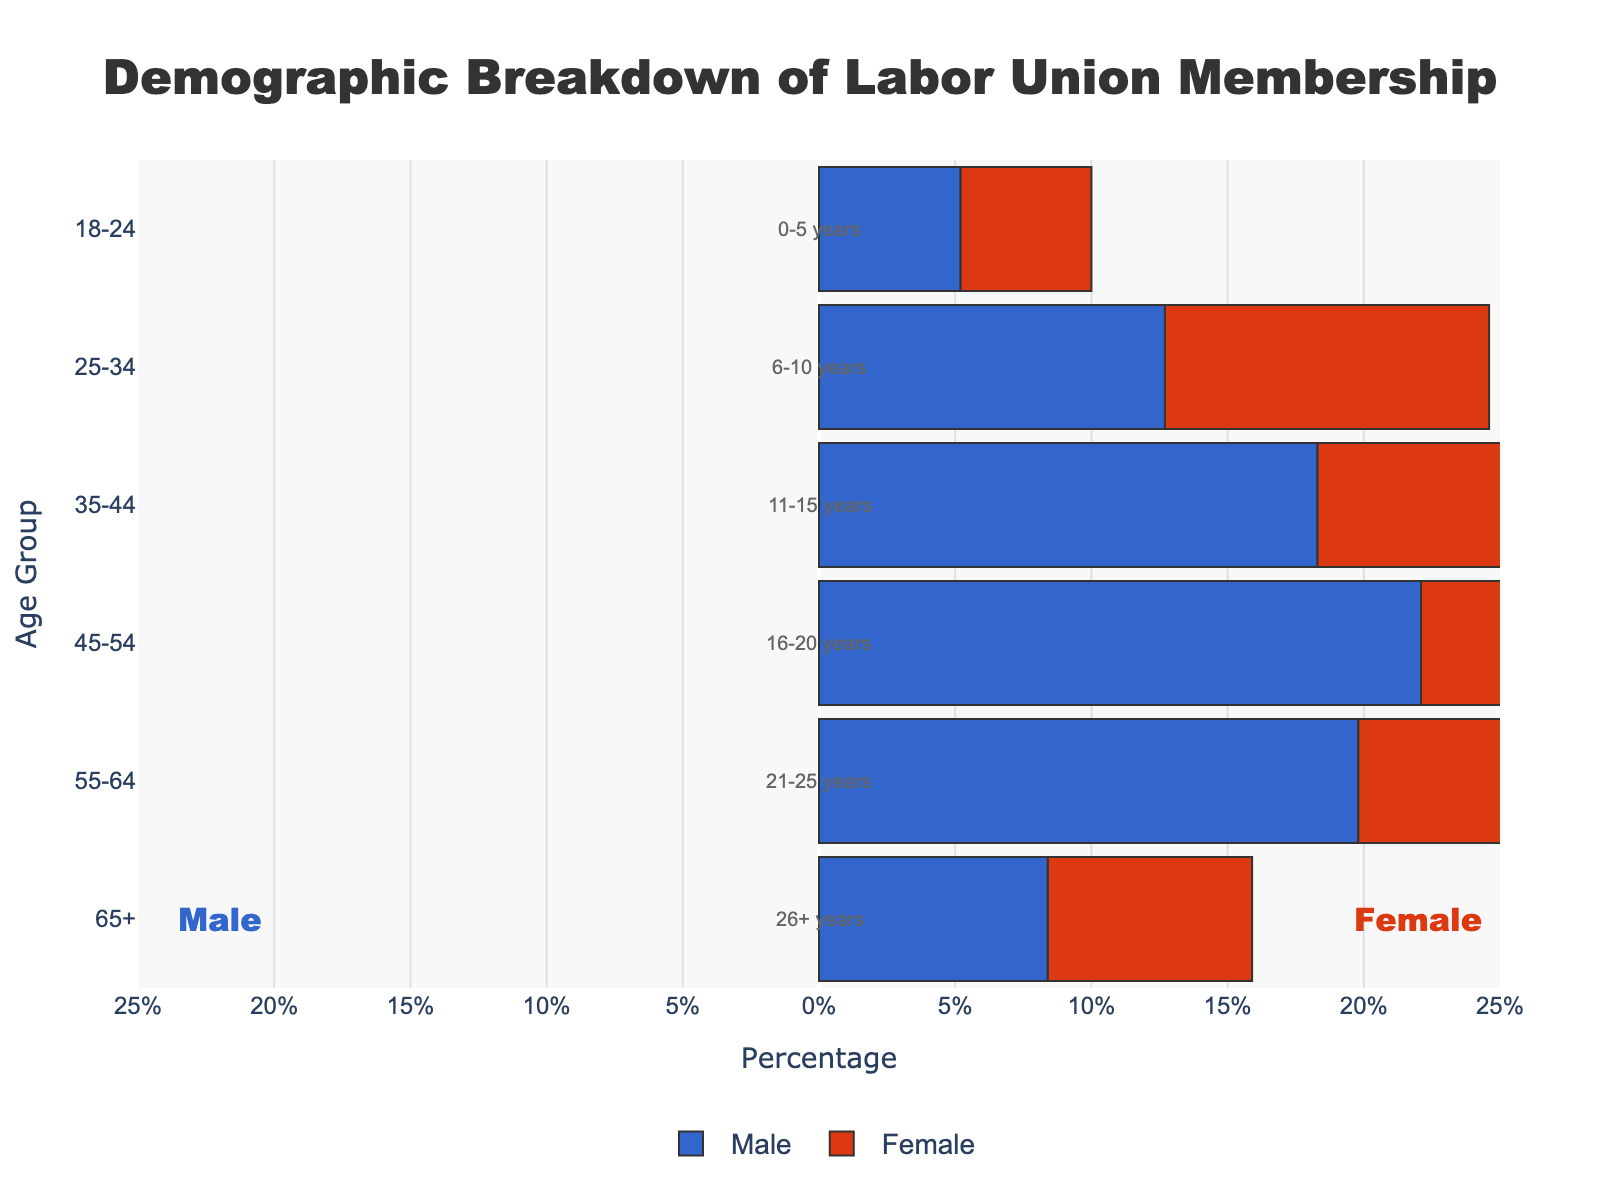What is the title of the figure? The title is located at the top center of the figure and states the main topic of the data being visualized. In this case, it reads "Demographic Breakdown of Labor Union Membership".
Answer: Demographic Breakdown of Labor Union Membership What age group has the smallest percentage of male union members? The horizontal axis shows percentages and the bars for different age groups, with male percentages on the left (negative values). The smallest percentage of male union members is in the 18-24 age group, which is -5.2%.
Answer: 18-24 How many age groups are depicted in the figure? Each horizontal bar represents an age group. By counting the number of bars, we find that there are six age groups depicted.
Answer: 6 What is the percentage difference between male and female union members in the 45-54 age group? The value for males in the 45-54 age group is -22.1% and for females, it is 21.6%. The difference is calculated as 22.1% + 21.6% = 43.7%.
Answer: 43.7% Which gender has more members in the 55-64 age group, and by what percentage? In the 55-64 age group, males have -19.8% and females have 19.2%. Females have more members. The difference is 19.2% - 19.8% = -0.6%. Ignoring the negative sign in the context here, the difference is 0.6%. Since females have a higher percentage, they have more members.
Answer: Female, 0.6% What is the employment duration for the 25-34 age group? Annotations on the plot provide information on the employment duration based on age groups. For the 25-34 age group, the duration is "6-10 years."
Answer: 6-10 years Which age group has the highest percentage of female union members? Looking at the bars on the right side of the pyramid (positive values), the 45-54 age group has the highest percentage of female union members with 21.6%.
Answer: 45-54 How much higher is the percentage of female union members than male union members in the 35-44 age group? Males have -18.3% and females have 17.5% in the 35-44 age group. The difference is 18.3% + 17.5% = 35.8%.
Answer: 35.8% What is the range of the x-axis in the figure? The x-axis displays percentages ranging from -25% to 25%, including negative values for males and positive values for females.
Answer: -25% to 25% In which age group do males have more members than females? There is no age group where the male percentage bar is greater (in absolute value) than the female percentage bar. All age groups show females having a larger or equal percentage. Therefore, males do not have more members than females in any age group.
Answer: None 